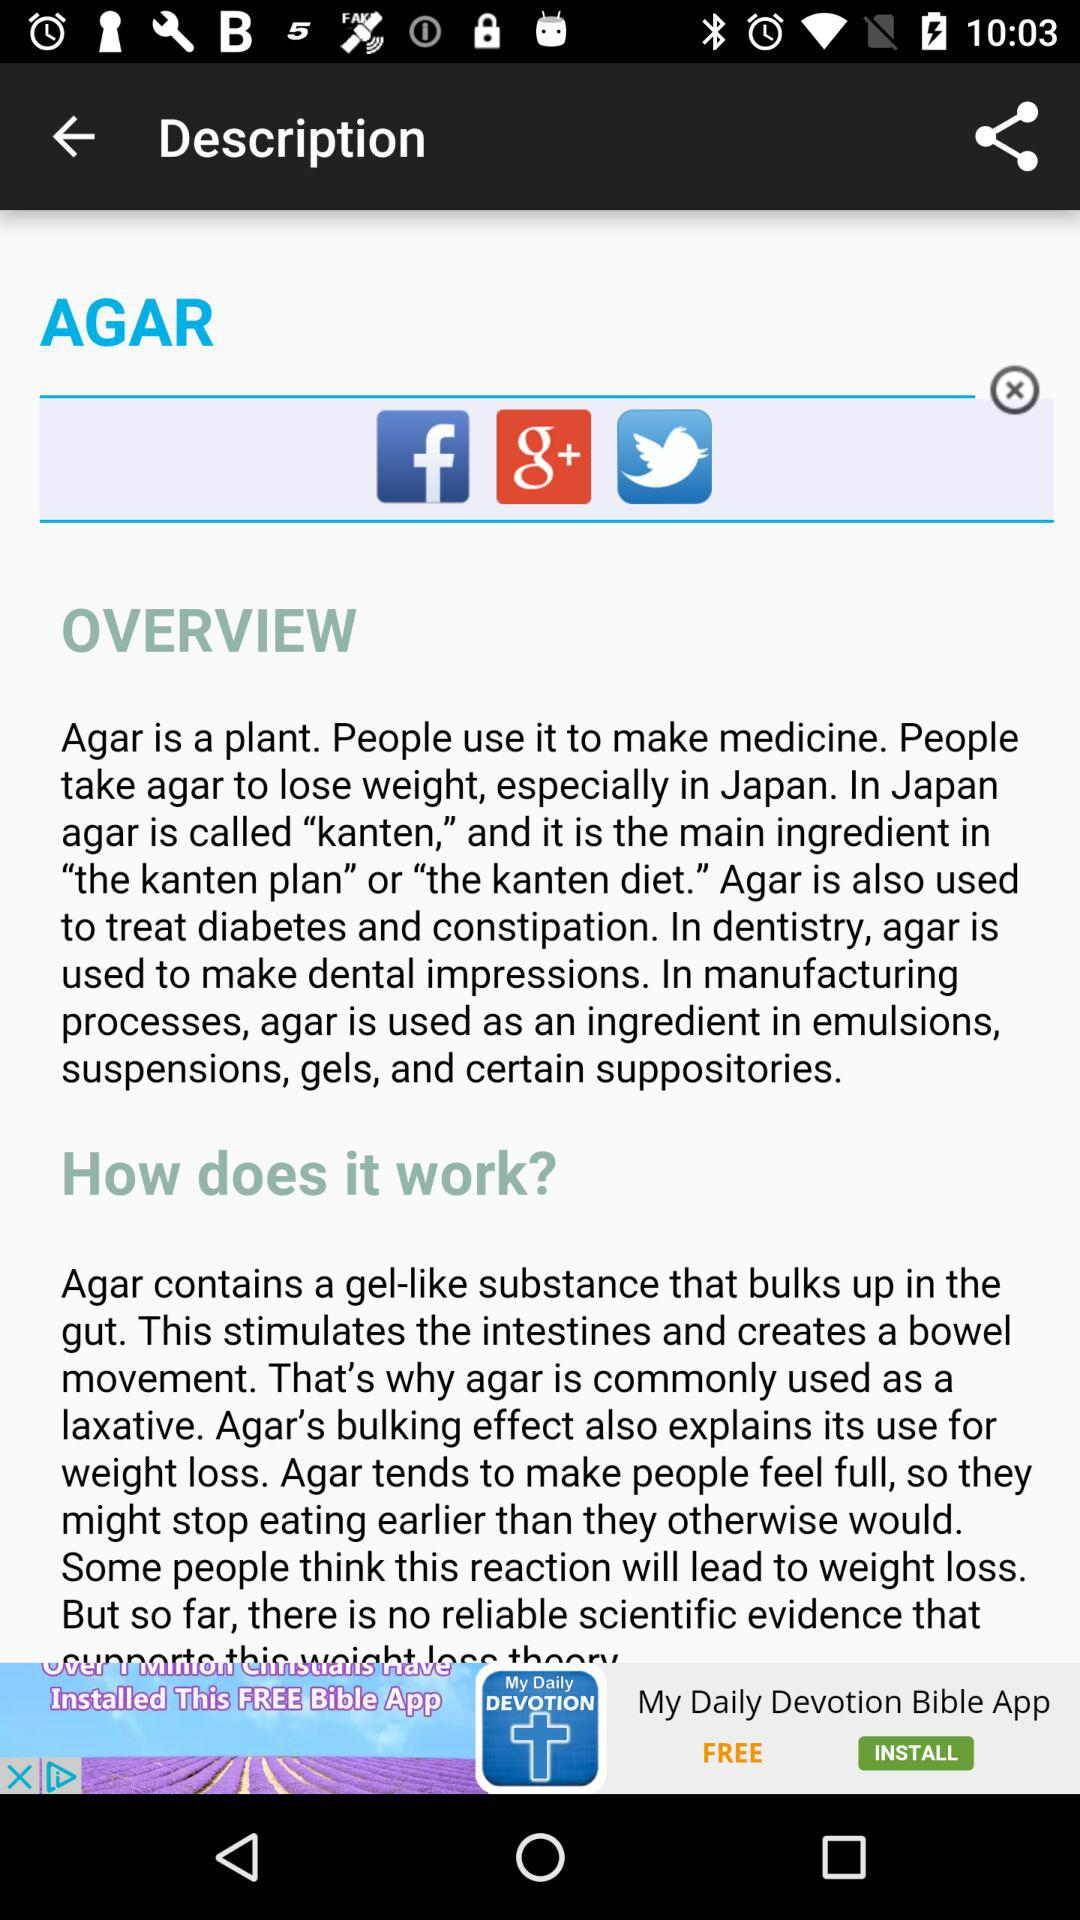What does agar contain? Agar contains a gel-like substance that bulks up in the gut. 